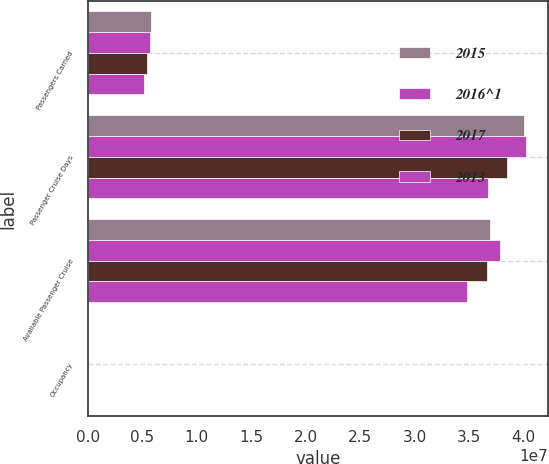Convert chart. <chart><loc_0><loc_0><loc_500><loc_500><stacked_bar_chart><ecel><fcel>Passengers Carried<fcel>Passenger Cruise Days<fcel>Available Passenger Cruise<fcel>Occupancy<nl><fcel>2015<fcel>5.7685e+06<fcel>4.00335e+07<fcel>3.69309e+07<fcel>108.4<nl><fcel>2016^1<fcel>5.75475e+06<fcel>4.02506e+07<fcel>3.78446e+07<fcel>106.4<nl><fcel>2017<fcel>5.4019e+06<fcel>3.85231e+07<fcel>3.66466e+07<fcel>105.1<nl><fcel>2013<fcel>5.14995e+06<fcel>3.6711e+07<fcel>3.47739e+07<fcel>105.6<nl></chart> 